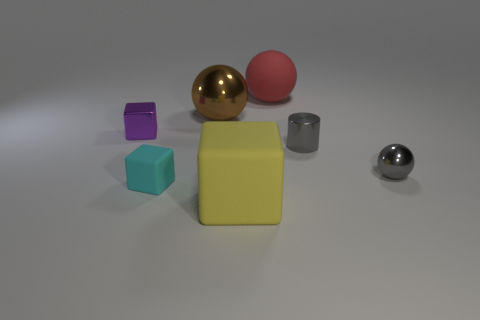How many brown objects are either metallic things or big rubber blocks? Upon examining the image, I can see there are no brown objects that can be conclusively identified as either metallic things or big rubber blocks. Therefore, the accurate count of brown objects that are either metallic things or big rubber blocks is zero. 